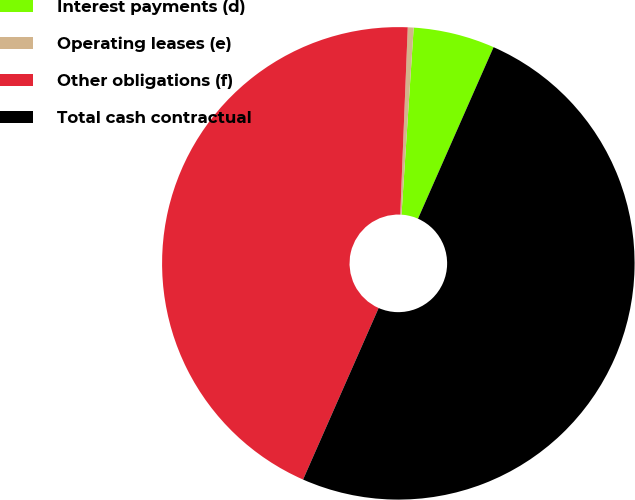<chart> <loc_0><loc_0><loc_500><loc_500><pie_chart><fcel>Interest payments (d)<fcel>Operating leases (e)<fcel>Other obligations (f)<fcel>Total cash contractual<nl><fcel>5.57%<fcel>0.4%<fcel>44.03%<fcel>50.0%<nl></chart> 